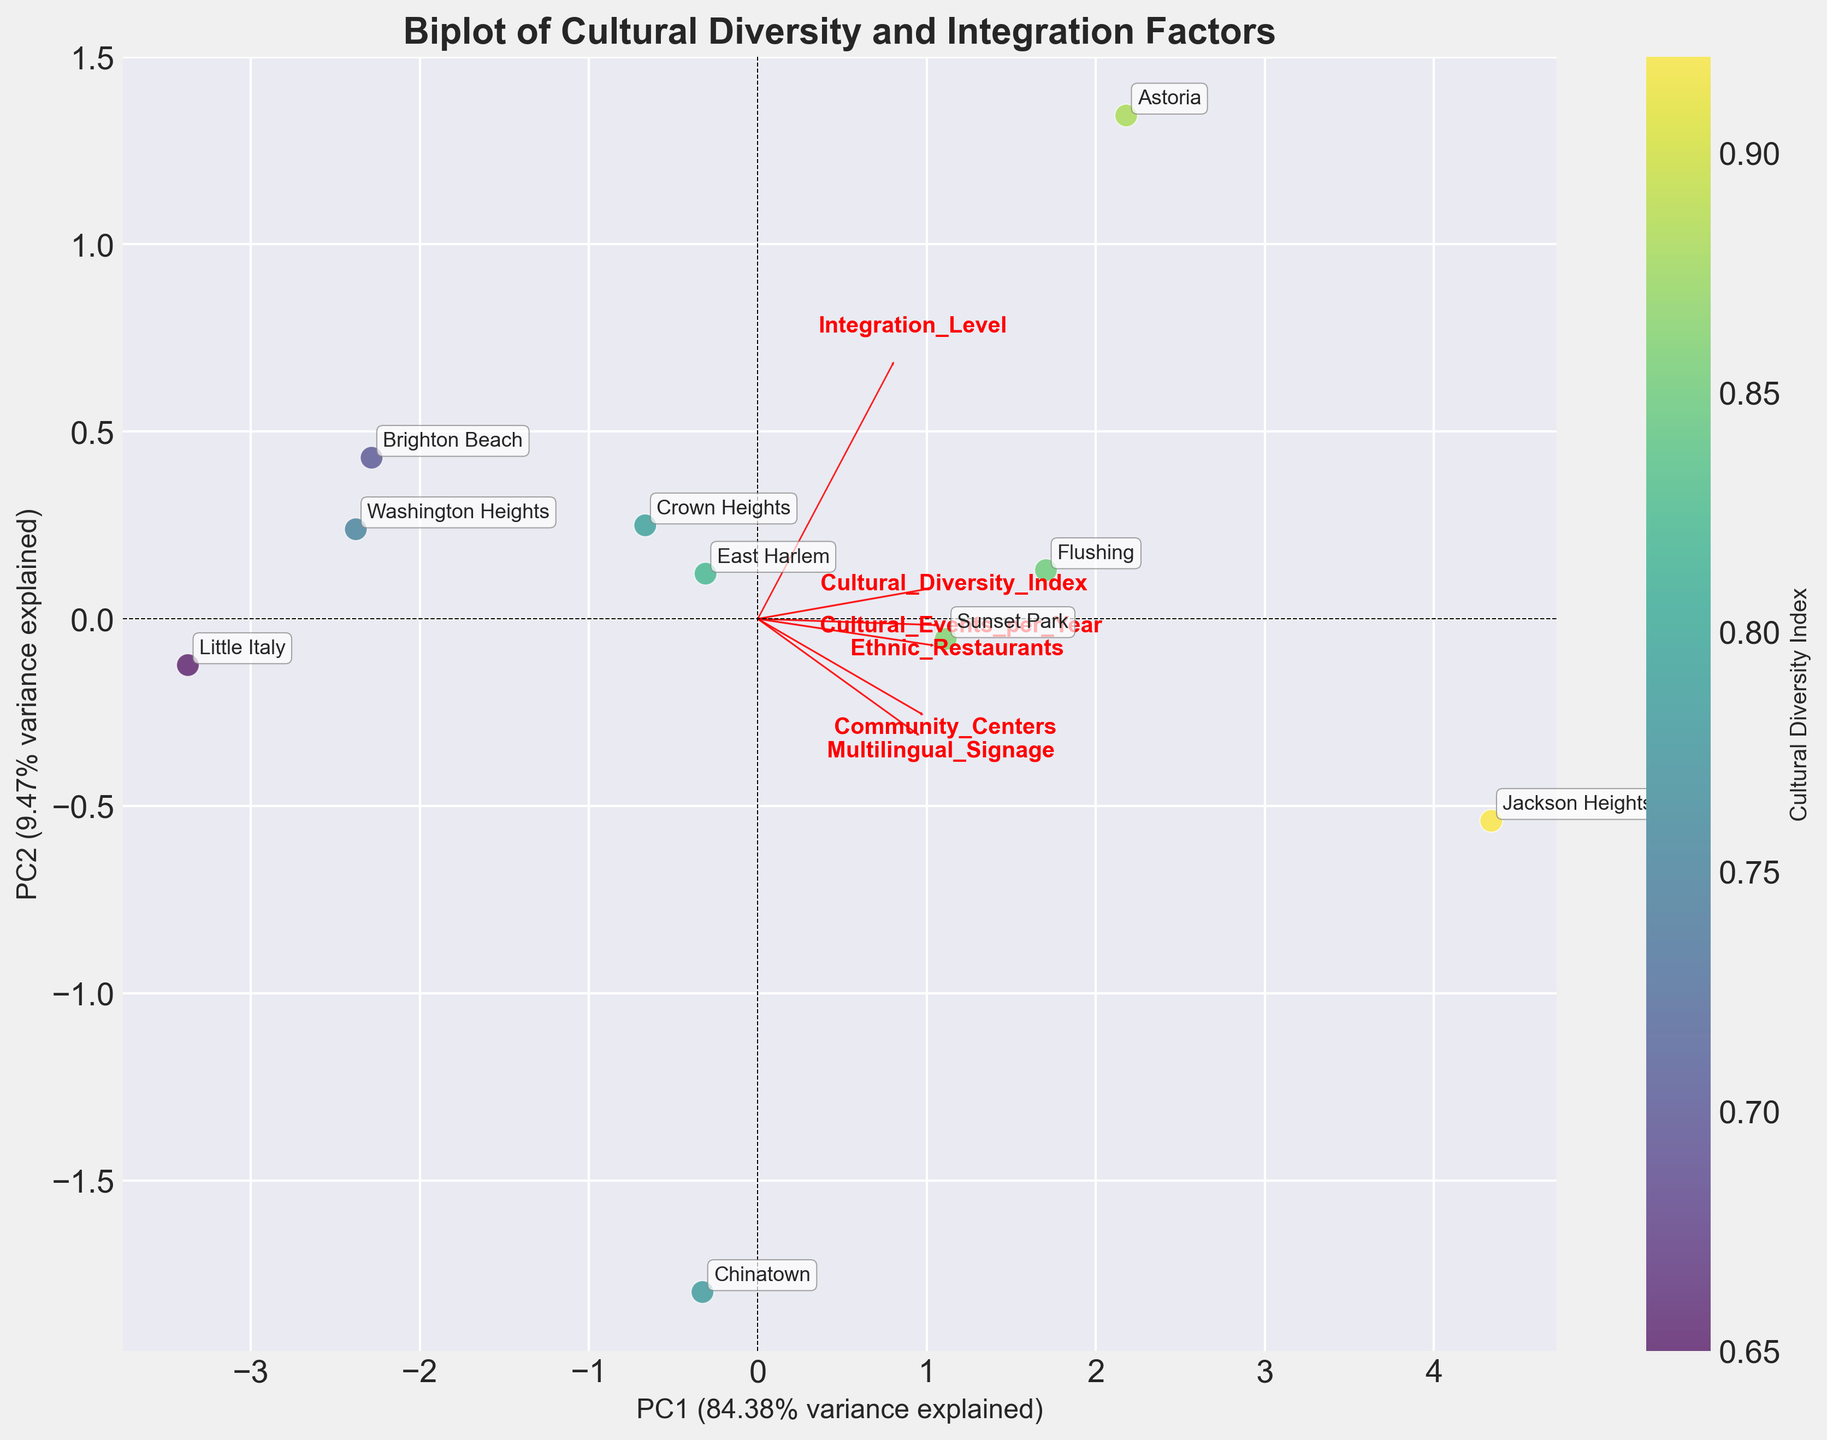What does the title of the Biplot indicate? The title provides an overview of what the figure is about. Here, the title "Biplot of Cultural Diversity and Integration Factors" suggests the plot is a biplot that represents cultural diversity and integration-related factors within different neighborhoods.
Answer: Biplot of Cultural Diversity and Integration Factors How many neighborhoods are represented in the Biplot? Count the number of labeled data points on the Biplot. Each label corresponds to a neighborhood.
Answer: 10 Which neighborhood has the highest Cultural Diversity Index? Look for the label with the highest value of Cultural Diversity Index indicated by the color of the scatter points.
Answer: Jackson Heights What does the color of the points represent? Refer to the colorbar to determine what the color of each data point signifies.
Answer: Cultural Diversity Index What are the two principal components in the Biplot? Examine the labels of the x-axis and y-axis. They represent the two principal components derived from PCA.
Answer: PC1 and PC2 Which two variables have the largest loading vectors on the biplot? Look for the arrows with the longest lengths, signifying the largest loading vectors.
Answer: Ethnic Restaurants, Cultural Events per Year How is the Integration Level of Chinatown compared to East Harlem? Identify the points corresponding to Chinatown and East Harlem and compare their positions related to the principal components.
Answer: Chinatown has a slightly lower Integration Level than East Harlem What is the approximate variance explained by PC1? Check the percentage of variance indicated in the label of the x-axis for PC1.
Answer: Approximately 36.2% Which feature is most closely aligned with PC2? Observe the feature whose arrow is most aligned with the y-axis (PC2).
Answer: Community Centers Are there any neighborhoods that seem to have similar cultural diversity and integration levels? Identify points that are closely positioned to each other on the plot.
Answer: Astoria and Jackson Heights 